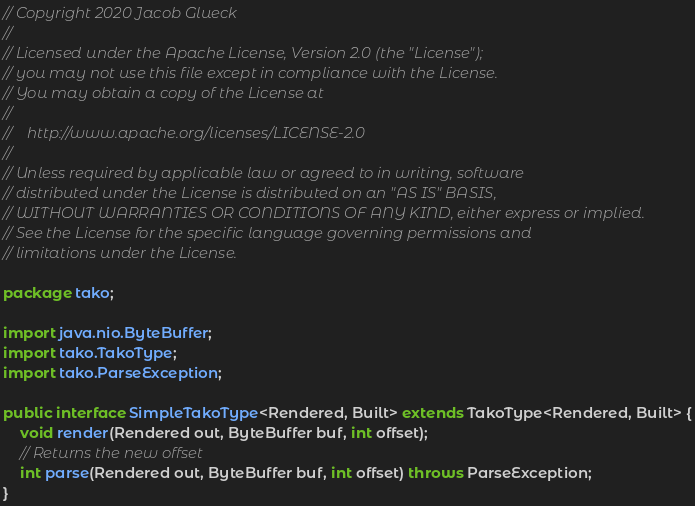<code> <loc_0><loc_0><loc_500><loc_500><_Java_>// Copyright 2020 Jacob Glueck
//
// Licensed under the Apache License, Version 2.0 (the "License");
// you may not use this file except in compliance with the License.
// You may obtain a copy of the License at
//
//    http://www.apache.org/licenses/LICENSE-2.0
//
// Unless required by applicable law or agreed to in writing, software
// distributed under the License is distributed on an "AS IS" BASIS,
// WITHOUT WARRANTIES OR CONDITIONS OF ANY KIND, either express or implied.
// See the License for the specific language governing permissions and
// limitations under the License.

package tako;

import java.nio.ByteBuffer;
import tako.TakoType;
import tako.ParseException;

public interface SimpleTakoType<Rendered, Built> extends TakoType<Rendered, Built> {
    void render(Rendered out, ByteBuffer buf, int offset);
    // Returns the new offset
    int parse(Rendered out, ByteBuffer buf, int offset) throws ParseException;
}
</code> 